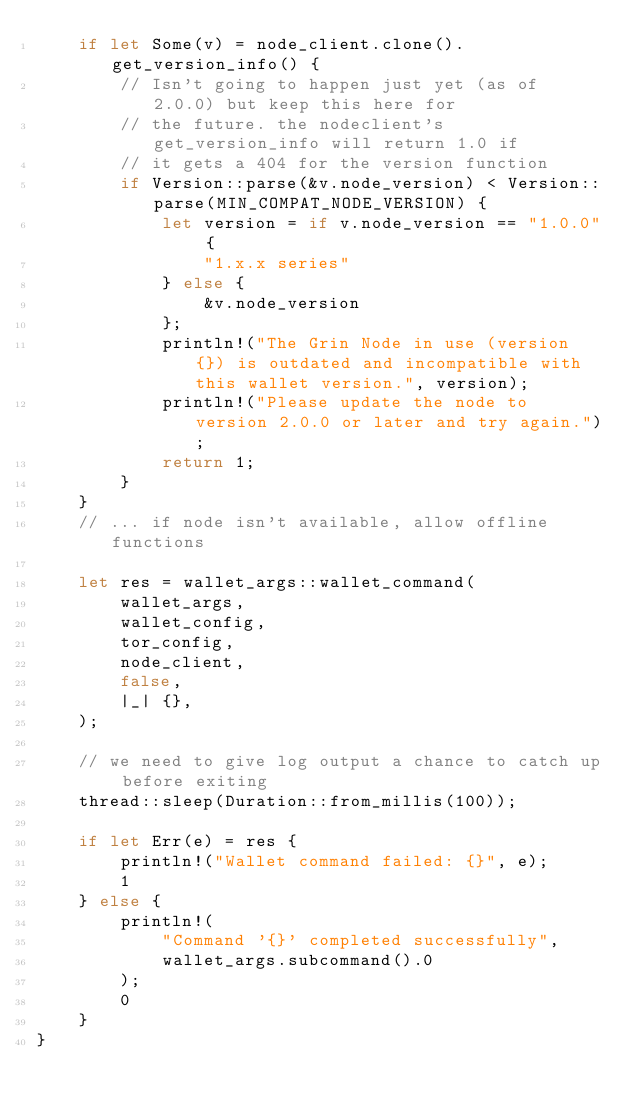Convert code to text. <code><loc_0><loc_0><loc_500><loc_500><_Rust_>	if let Some(v) = node_client.clone().get_version_info() {
		// Isn't going to happen just yet (as of 2.0.0) but keep this here for
		// the future. the nodeclient's get_version_info will return 1.0 if
		// it gets a 404 for the version function
		if Version::parse(&v.node_version) < Version::parse(MIN_COMPAT_NODE_VERSION) {
			let version = if v.node_version == "1.0.0" {
				"1.x.x series"
			} else {
				&v.node_version
			};
			println!("The Grin Node in use (version {}) is outdated and incompatible with this wallet version.", version);
			println!("Please update the node to version 2.0.0 or later and try again.");
			return 1;
		}
	}
	// ... if node isn't available, allow offline functions

	let res = wallet_args::wallet_command(
		wallet_args,
		wallet_config,
		tor_config,
		node_client,
		false,
		|_| {},
	);

	// we need to give log output a chance to catch up before exiting
	thread::sleep(Duration::from_millis(100));

	if let Err(e) = res {
		println!("Wallet command failed: {}", e);
		1
	} else {
		println!(
			"Command '{}' completed successfully",
			wallet_args.subcommand().0
		);
		0
	}
}
</code> 